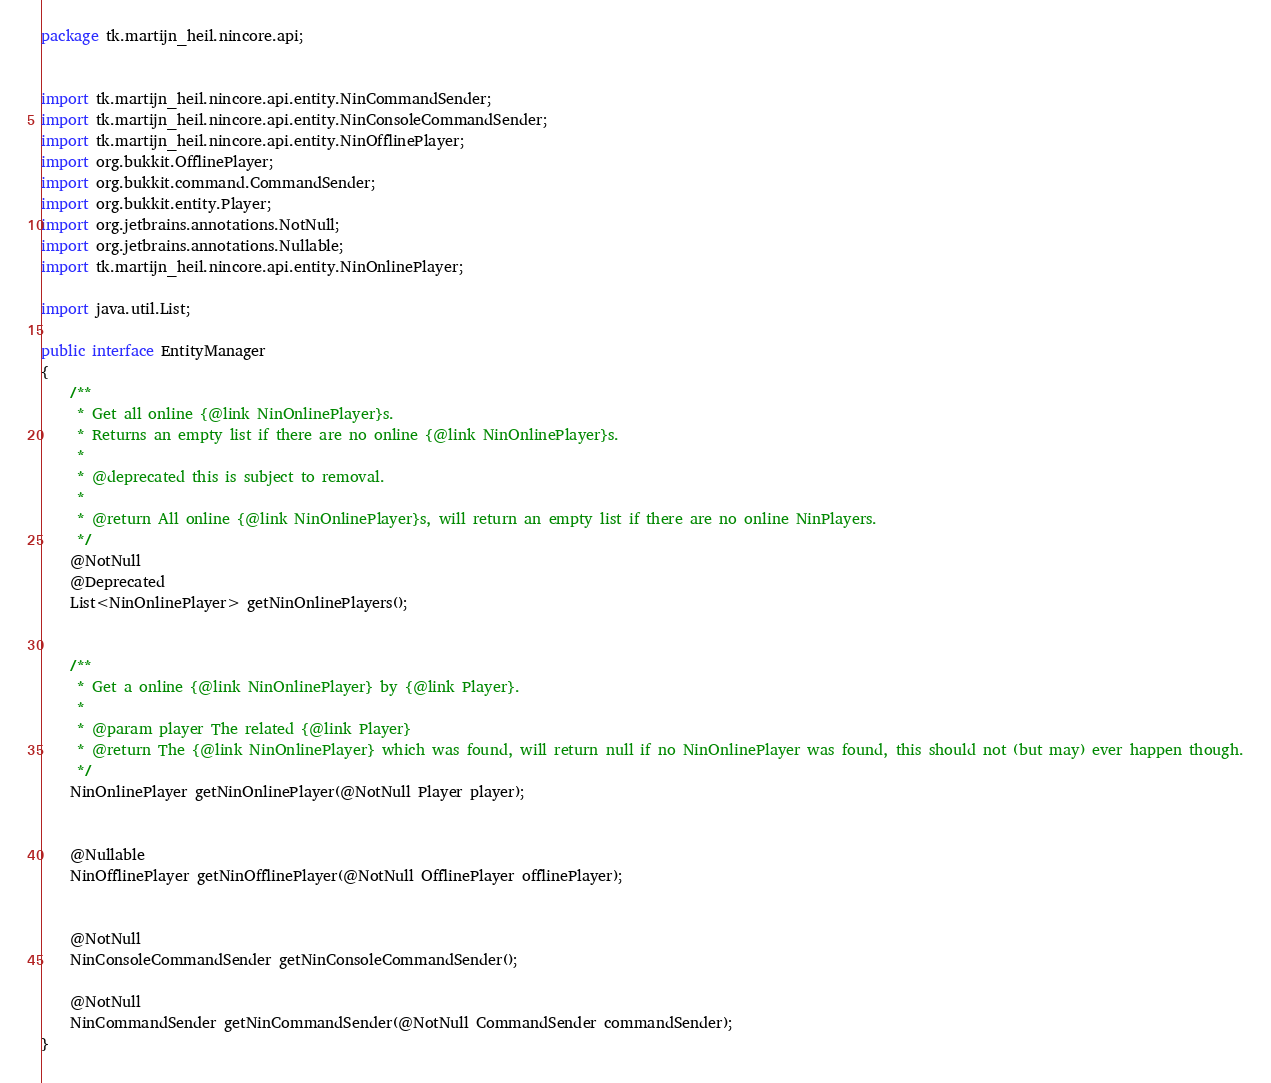Convert code to text. <code><loc_0><loc_0><loc_500><loc_500><_Java_>package tk.martijn_heil.nincore.api;


import tk.martijn_heil.nincore.api.entity.NinCommandSender;
import tk.martijn_heil.nincore.api.entity.NinConsoleCommandSender;
import tk.martijn_heil.nincore.api.entity.NinOfflinePlayer;
import org.bukkit.OfflinePlayer;
import org.bukkit.command.CommandSender;
import org.bukkit.entity.Player;
import org.jetbrains.annotations.NotNull;
import org.jetbrains.annotations.Nullable;
import tk.martijn_heil.nincore.api.entity.NinOnlinePlayer;

import java.util.List;

public interface EntityManager
{
    /**
     * Get all online {@link NinOnlinePlayer}s.
     * Returns an empty list if there are no online {@link NinOnlinePlayer}s.
     *
     * @deprecated this is subject to removal.
     *
     * @return All online {@link NinOnlinePlayer}s, will return an empty list if there are no online NinPlayers.
     */
    @NotNull
    @Deprecated
    List<NinOnlinePlayer> getNinOnlinePlayers();


    /**
     * Get a online {@link NinOnlinePlayer} by {@link Player}.
     *
     * @param player The related {@link Player}
     * @return The {@link NinOnlinePlayer} which was found, will return null if no NinOnlinePlayer was found, this should not (but may) ever happen though.
     */
    NinOnlinePlayer getNinOnlinePlayer(@NotNull Player player);


    @Nullable
    NinOfflinePlayer getNinOfflinePlayer(@NotNull OfflinePlayer offlinePlayer);


    @NotNull
    NinConsoleCommandSender getNinConsoleCommandSender();

    @NotNull
    NinCommandSender getNinCommandSender(@NotNull CommandSender commandSender);
}
</code> 